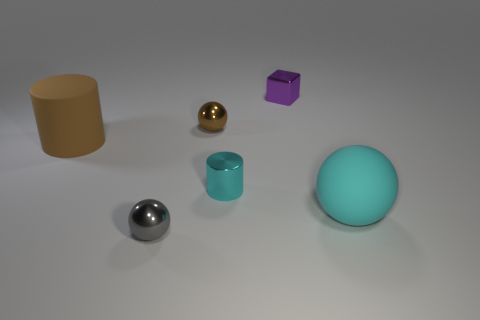Add 3 small green cylinders. How many objects exist? 9 Subtract all blocks. How many objects are left? 5 Subtract all large gray spheres. Subtract all large cylinders. How many objects are left? 5 Add 4 gray metallic spheres. How many gray metallic spheres are left? 5 Add 2 large matte cylinders. How many large matte cylinders exist? 3 Subtract 0 purple cylinders. How many objects are left? 6 